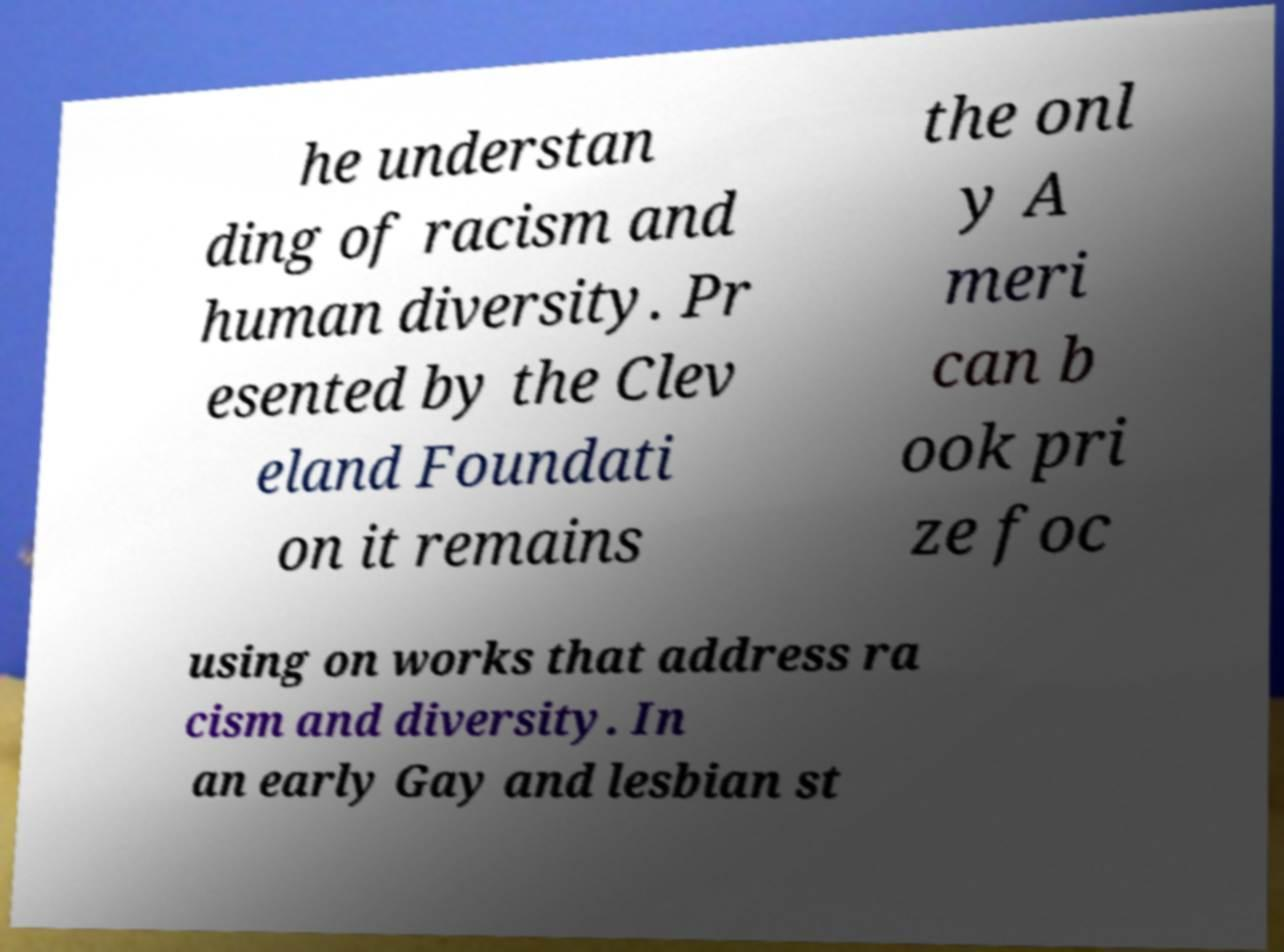There's text embedded in this image that I need extracted. Can you transcribe it verbatim? he understan ding of racism and human diversity. Pr esented by the Clev eland Foundati on it remains the onl y A meri can b ook pri ze foc using on works that address ra cism and diversity. In an early Gay and lesbian st 